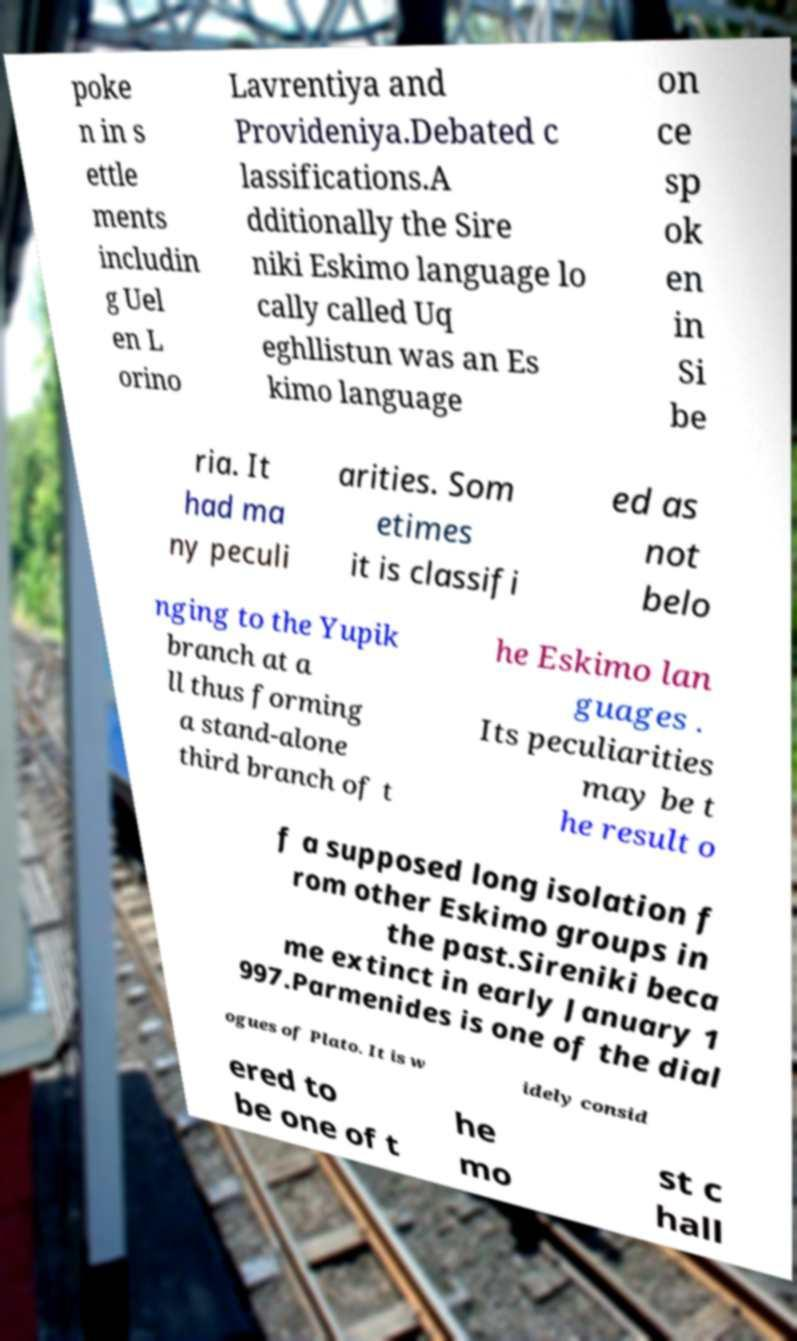What messages or text are displayed in this image? I need them in a readable, typed format. poke n in s ettle ments includin g Uel en L orino Lavrentiya and Provideniya.Debated c lassifications.A dditionally the Sire niki Eskimo language lo cally called Uq eghllistun was an Es kimo language on ce sp ok en in Si be ria. It had ma ny peculi arities. Som etimes it is classifi ed as not belo nging to the Yupik branch at a ll thus forming a stand-alone third branch of t he Eskimo lan guages . Its peculiarities may be t he result o f a supposed long isolation f rom other Eskimo groups in the past.Sireniki beca me extinct in early January 1 997.Parmenides is one of the dial ogues of Plato. It is w idely consid ered to be one of t he mo st c hall 